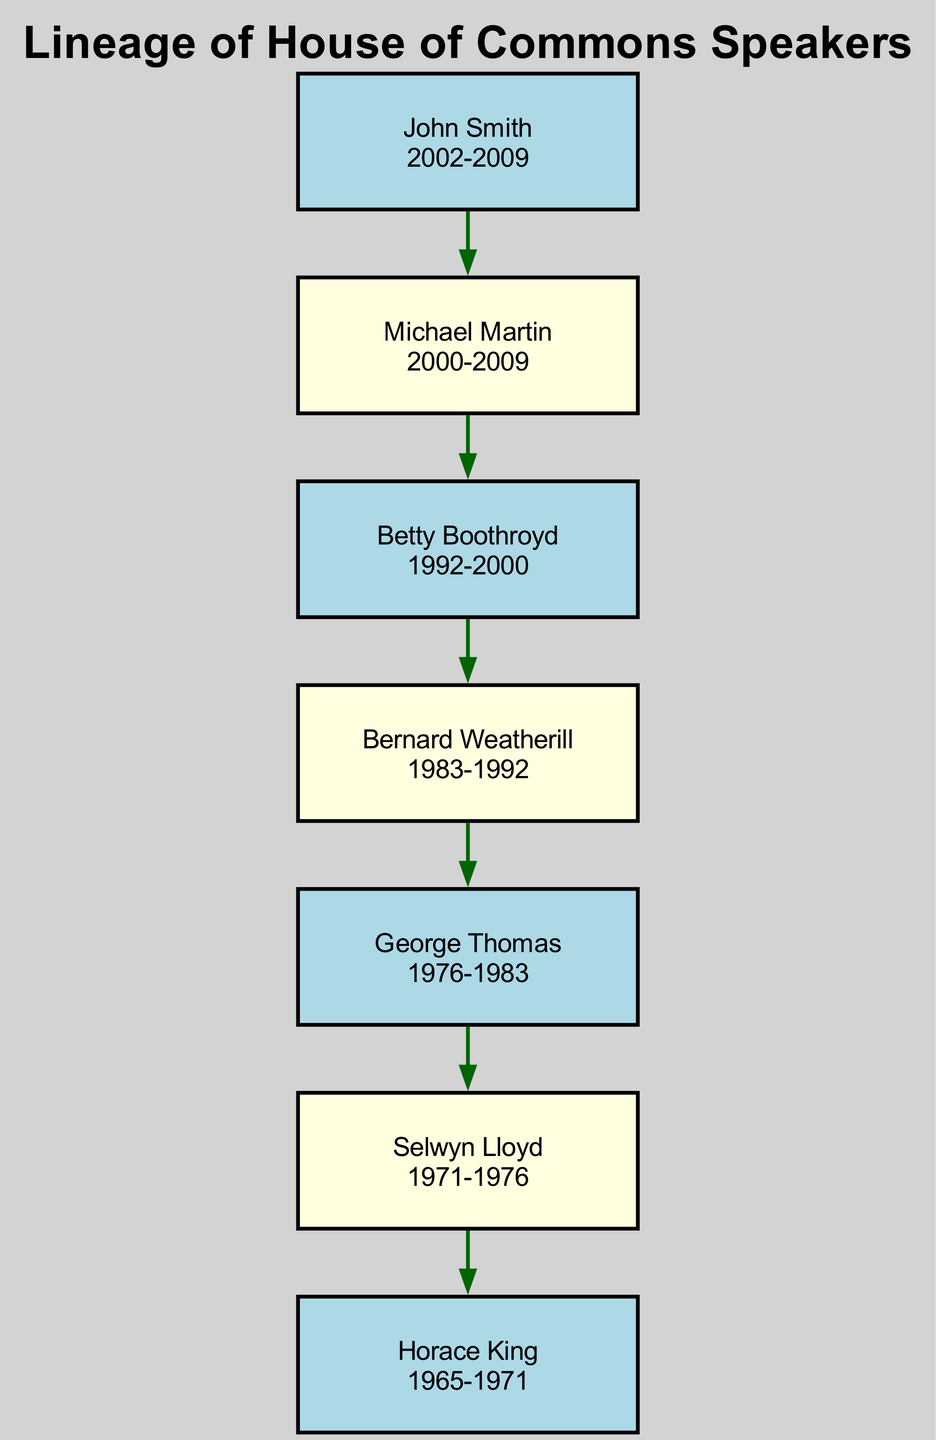What is the name of the Speaker who served from 1992 to 2000? The diagram lists Betty Boothroyd as the Speaker for the term 1992 to 2000. This is evident from the node containing her name and the corresponding term dates.
Answer: Betty Boothroyd How many Speakers are represented in the diagram? The diagram contains a total of 7 distinct speakers, each represented by their own node. By counting the nodes, we confirm there are 7 speakers.
Answer: 7 Who was the Speaker immediately before John Smith? The diagram shows that Michael Martin served as Speaker immediately before John Smith from 2000 to 2009. The edge between Martin and Smith indicates this succession.
Answer: Michael Martin In what year did George Thomas start his term? According to the diagram, George Thomas started his term in 1976, as stated in the node detailing his term dates.
Answer: 1976 Which Speaker had the longest term in office? To determine this, we need to examine the start and end dates for all speakers. The longest term belonged to Michael Martin, who served from 2000 to 2009, which is a total of 9 years.
Answer: Michael Martin How many years did Selwyn Lloyd serve as Speaker? Selwyn Lloyd's term is shown in the diagram as 1971 to 1976. Calculating the duration from the start to the end year gives us 5 years.
Answer: 5 years What is the relationship between Betty Boothroyd and Bernard Weatherill? The diagram illustrates that Betty Boothroyd follows Bernard Weatherill in the lineage, meaning Boothroyd succeeded Weatherill as Speaker of the House of Commons.
Answer: Successor Which Speaker served in the year 1985? By examining the terms of each Speaker in the diagram, we find that Bernard Weatherill served during 1985 (from 1983 to 1992), confirming this through the timeline of his term.
Answer: Bernard Weatherill What was the last term of Horace King? The diagram indicates that Horace King served until 1971, thus making that the last year of his term as Speaker.
Answer: 1971 